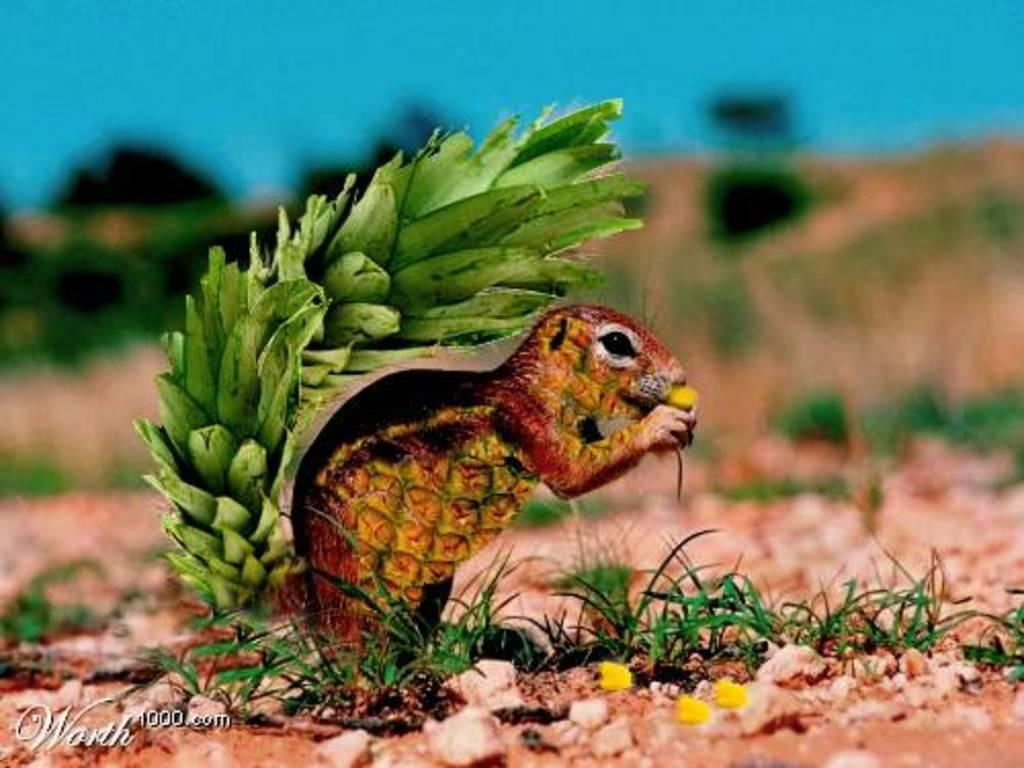What type of image is in the picture? A: There is an animated image of an animal in the picture. What is the animal doing in the image? The animal is holding an object in the image. Where is the animal located in the image? The animal is standing on the ground in the image. How would you describe the background of the image? The background of the image is blurry. What type of fruit is being treated in the hospital in the image? There is no fruit or hospital present in the image; it features an animated animal holding an object and standing on the ground with a blurry background. 